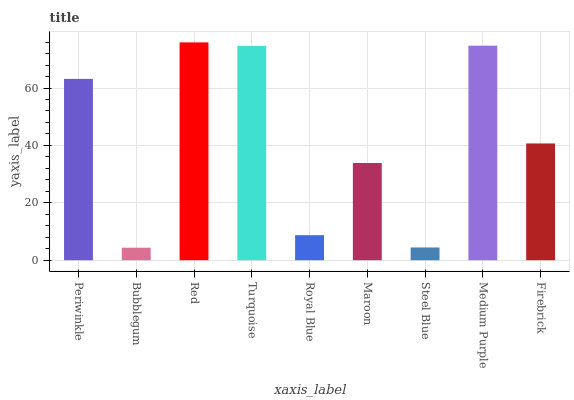Is Bubblegum the minimum?
Answer yes or no. Yes. Is Red the maximum?
Answer yes or no. Yes. Is Red the minimum?
Answer yes or no. No. Is Bubblegum the maximum?
Answer yes or no. No. Is Red greater than Bubblegum?
Answer yes or no. Yes. Is Bubblegum less than Red?
Answer yes or no. Yes. Is Bubblegum greater than Red?
Answer yes or no. No. Is Red less than Bubblegum?
Answer yes or no. No. Is Firebrick the high median?
Answer yes or no. Yes. Is Firebrick the low median?
Answer yes or no. Yes. Is Red the high median?
Answer yes or no. No. Is Royal Blue the low median?
Answer yes or no. No. 